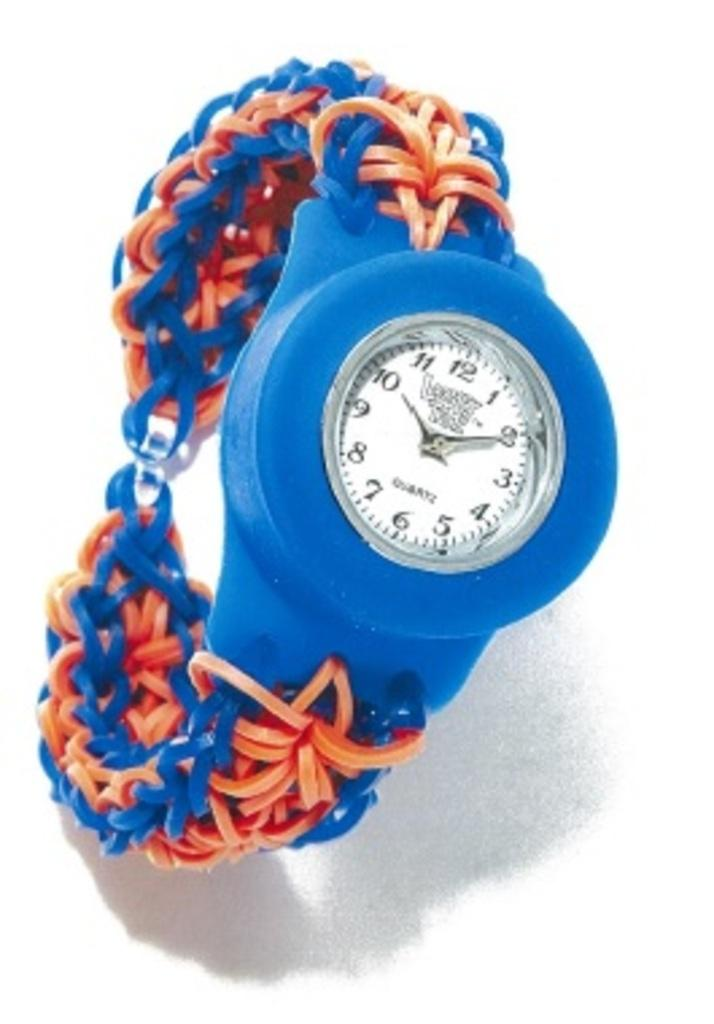Provide a one-sentence caption for the provided image. A wrist watch with the time of 10:10 is displayed. 